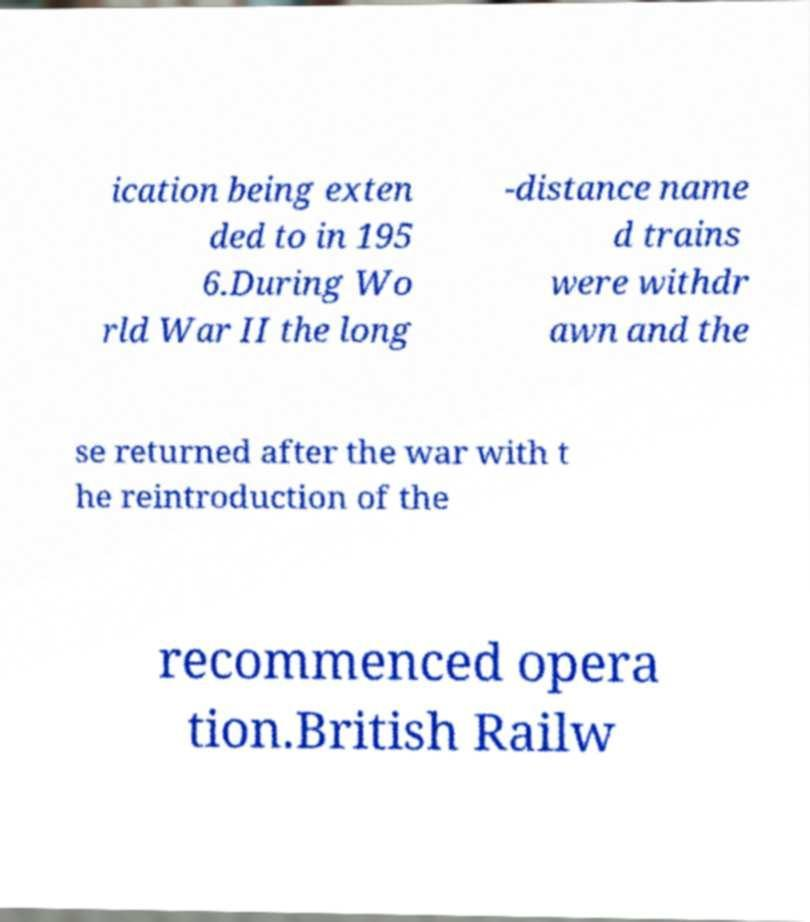What messages or text are displayed in this image? I need them in a readable, typed format. ication being exten ded to in 195 6.During Wo rld War II the long -distance name d trains were withdr awn and the se returned after the war with t he reintroduction of the recommenced opera tion.British Railw 